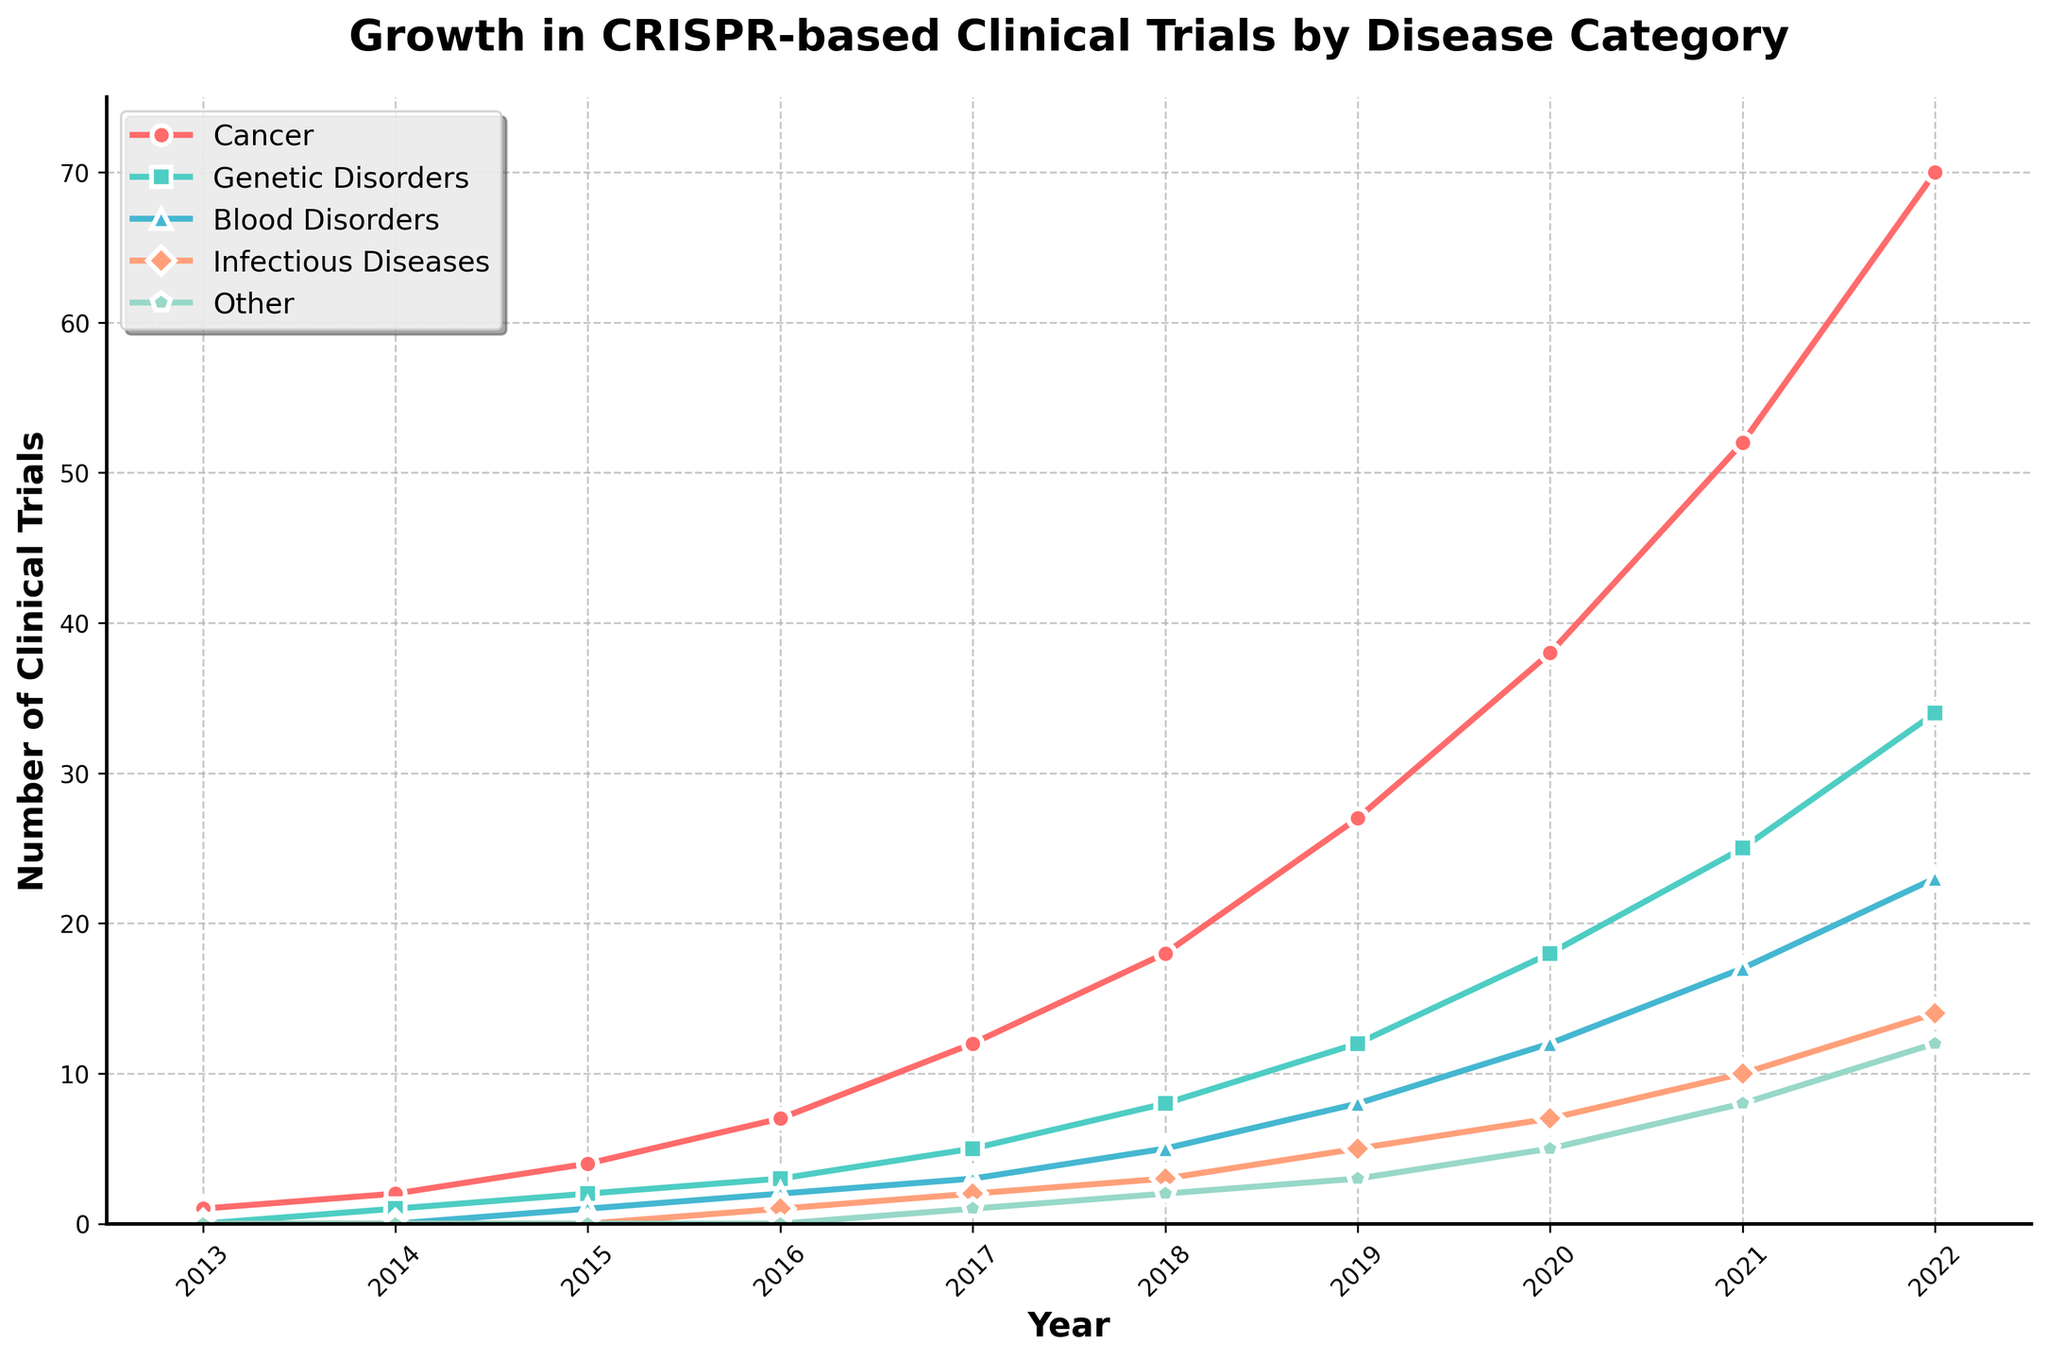What is the trend in the number of CRISPR-based clinical trials targeting cancer from 2013 to 2022? To determine the trend, observe the line corresponding to cancer, which starts at 1 in 2013 and rises steadily to 70 by 2022, indicating a consistent increase in trials over the years.
Answer: Increasing Which category experienced the largest growth in the number of clinical trials from 2016 to 2020? Look at the differences in the number of trials from 2016 to 2020 for each category: Cancer (38-7=31), Genetic Disorders (18-3=15), Blood Disorders (12-2=10), Infectious Diseases (7-1=6), Other (5-0=5). The largest growth is in the Cancer category.
Answer: Cancer By how much did the number of clinical trials for genetic disorders increase from 2015 to 2022? The number of clinical trials for genetic disorders increased from 2 in 2015 to 34 in 2022. The increase is 34 - 2 = 32.
Answer: 32 Were there any diseases that started with 0 clinical trials in 2013 but had trials by 2017? Compare the data for 2013 and 2017. The "Genetic Disorders," "Blood Disorders," "Infectious Diseases," and "Other" categories started with 0 in 2013. By 2017, all except "Blood Disorders" had non-zero values.
Answer: Yes, Genetic Disorders, Infectious Diseases, Other Which disease had the fewest number of trials in 2022? Look at the numbers for 2022: Cancer (70), Genetic Disorders (34), Blood Disorders (23), Infectious Diseases (14), Other (12). The fewest is in "Other" with 12 trials.
Answer: Other How does the number of CRISPR-based clinical trials for infectious diseases in 2022 compare to those in 2019? The number of trials for infectious diseases was 5 in 2019 and 14 in 2022. By calculating, 14 - 5 = 9, the trials increased by 9.
Answer: Increased by 9 Which disease had the most rapidly increasing number of clinical trials between 2019 and 2022, visually? Visually examine the steepness of the slopes between 2019 and 2022. The slope for Cancer rises most steeply from 27 to 70, making Cancer the most rapidly increasing one.
Answer: Cancer Did any disease category show a decline or plateau in any year's clinical trial numbers? By inspecting the plot for any dips or flat lines, it is evident that all categories show a continuous upward trend with no declines or plateaus.
Answer: No What was the total number of clinical trials across all disease categories in 2018? Sum the number of trials for all categories in 2018: Cancer (18) + Genetic Disorders (8) + Blood Disorders (5) + Infectious Diseases (3) + Other (2) = 36.
Answer: 36 Which two disease categories had the closest number of clinical trials in any given year? Check each year's data for categories with close numbers. In 2020, "Infectious Diseases" had 7, and "Other" had 5, which are closest compared to other years.
Answer: Infectious Diseases and Other in 2020 